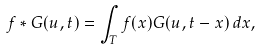Convert formula to latex. <formula><loc_0><loc_0><loc_500><loc_500>f * G ( u , t ) = \int _ { T } f ( x ) G ( u , t - x ) \, d x ,</formula> 